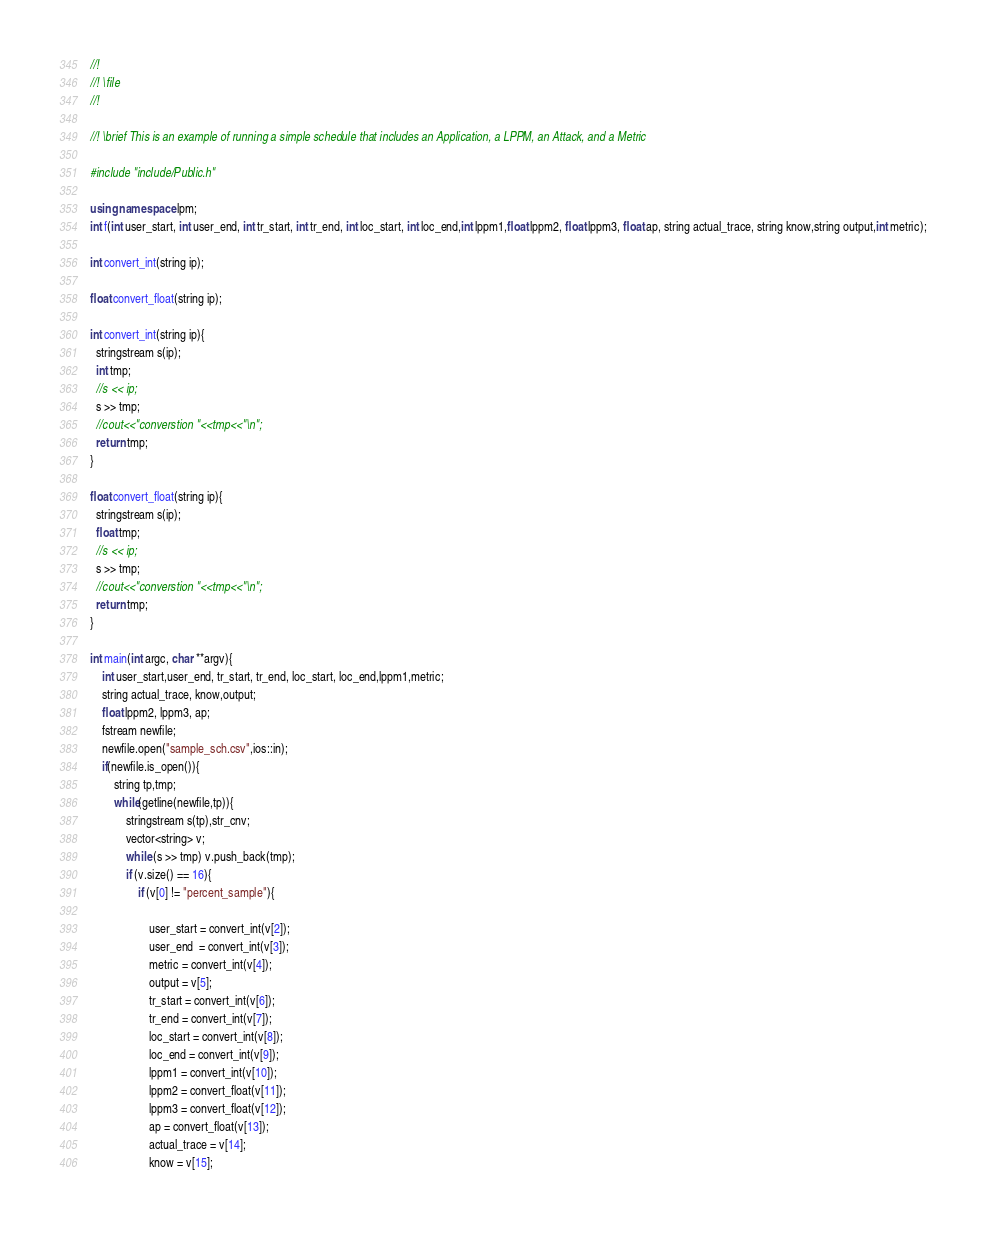<code> <loc_0><loc_0><loc_500><loc_500><_C++_>//!
//! \file
//!

//! \brief This is an example of running a simple schedule that includes an Application, a LPPM, an Attack, and a Metric

#include "include/Public.h" 

using namespace lpm;
int f(int user_start, int user_end, int tr_start, int tr_end, int loc_start, int loc_end,int lppm1,float lppm2, float lppm3, float ap, string actual_trace, string know,string output,int metric);

int convert_int(string ip);

float convert_float(string ip);

int convert_int(string ip){
  stringstream s(ip);
  int tmp;
  //s << ip;
  s >> tmp;
  //cout<<"converstion "<<tmp<<"\n";
  return tmp;
}

float convert_float(string ip){
  stringstream s(ip);
  float tmp;
  //s << ip;
  s >> tmp;
  //cout<<"converstion "<<tmp<<"\n";
  return tmp;
}

int main(int argc, char **argv){
    int user_start,user_end, tr_start, tr_end, loc_start, loc_end,lppm1,metric;
    string actual_trace, know,output;
    float lppm2, lppm3, ap; 
    fstream newfile;
    newfile.open("sample_sch.csv",ios::in);
    if(newfile.is_open()){
        string tp,tmp;
        while(getline(newfile,tp)){
            stringstream s(tp),str_cnv;
            vector<string> v;
            while (s >> tmp) v.push_back(tmp);
            if (v.size() == 16){
                if (v[0] != "percent_sample"){

                    user_start = convert_int(v[2]);
                    user_end  = convert_int(v[3]);
                    metric = convert_int(v[4]);
					output = v[5];
					tr_start = convert_int(v[6]);
					tr_end = convert_int(v[7]);         
					loc_start = convert_int(v[8]);
					loc_end = convert_int(v[9]);
					lppm1 = convert_int(v[10]);
					lppm2 = convert_float(v[11]);
					lppm3 = convert_float(v[12]);  
					ap = convert_float(v[13]);
					actual_trace = v[14]; 
					know = v[15];</code> 